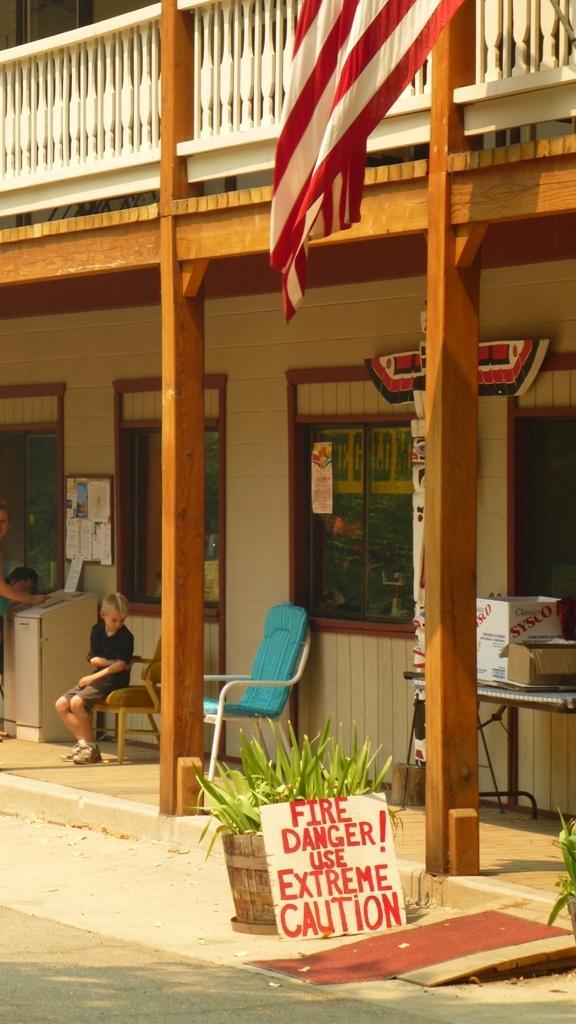Can you describe this image briefly? In this picture we can see two chairs one person is sitting on the chair and this is the building we can see about potted plants and board and one flag. 